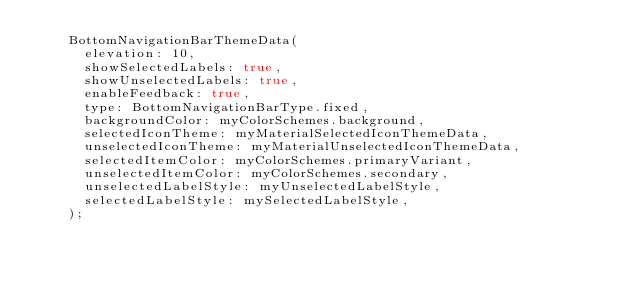Convert code to text. <code><loc_0><loc_0><loc_500><loc_500><_Dart_>    BottomNavigationBarThemeData(
      elevation: 10,
      showSelectedLabels: true,
      showUnselectedLabels: true,
      enableFeedback: true,
      type: BottomNavigationBarType.fixed,
      backgroundColor: myColorSchemes.background,
      selectedIconTheme: myMaterialSelectedIconThemeData,
      unselectedIconTheme: myMaterialUnselectedIconThemeData,
      selectedItemColor: myColorSchemes.primaryVariant,
      unselectedItemColor: myColorSchemes.secondary,
      unselectedLabelStyle: myUnselectedLabelStyle,
      selectedLabelStyle: mySelectedLabelStyle,
    );


</code> 